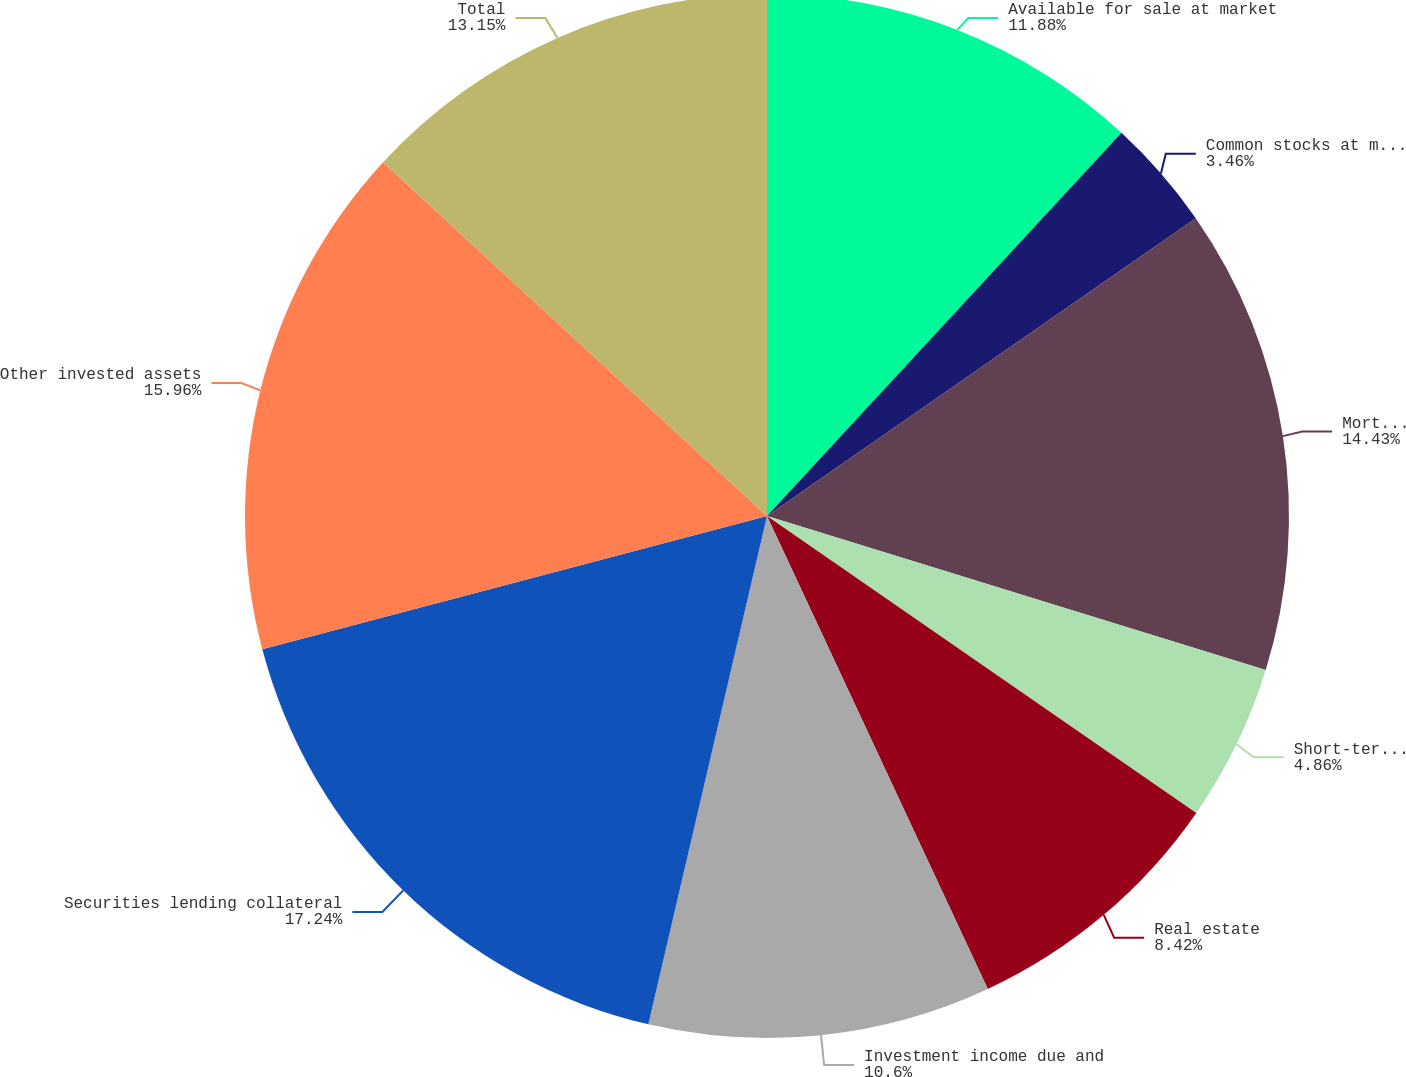Convert chart to OTSL. <chart><loc_0><loc_0><loc_500><loc_500><pie_chart><fcel>Available for sale at market<fcel>Common stocks at market value<fcel>Mortgage loans on real estate<fcel>Short-term investments<fcel>Real estate<fcel>Investment income due and<fcel>Securities lending collateral<fcel>Other invested assets<fcel>Total<nl><fcel>11.88%<fcel>3.46%<fcel>14.43%<fcel>4.86%<fcel>8.42%<fcel>10.6%<fcel>17.24%<fcel>15.96%<fcel>13.15%<nl></chart> 